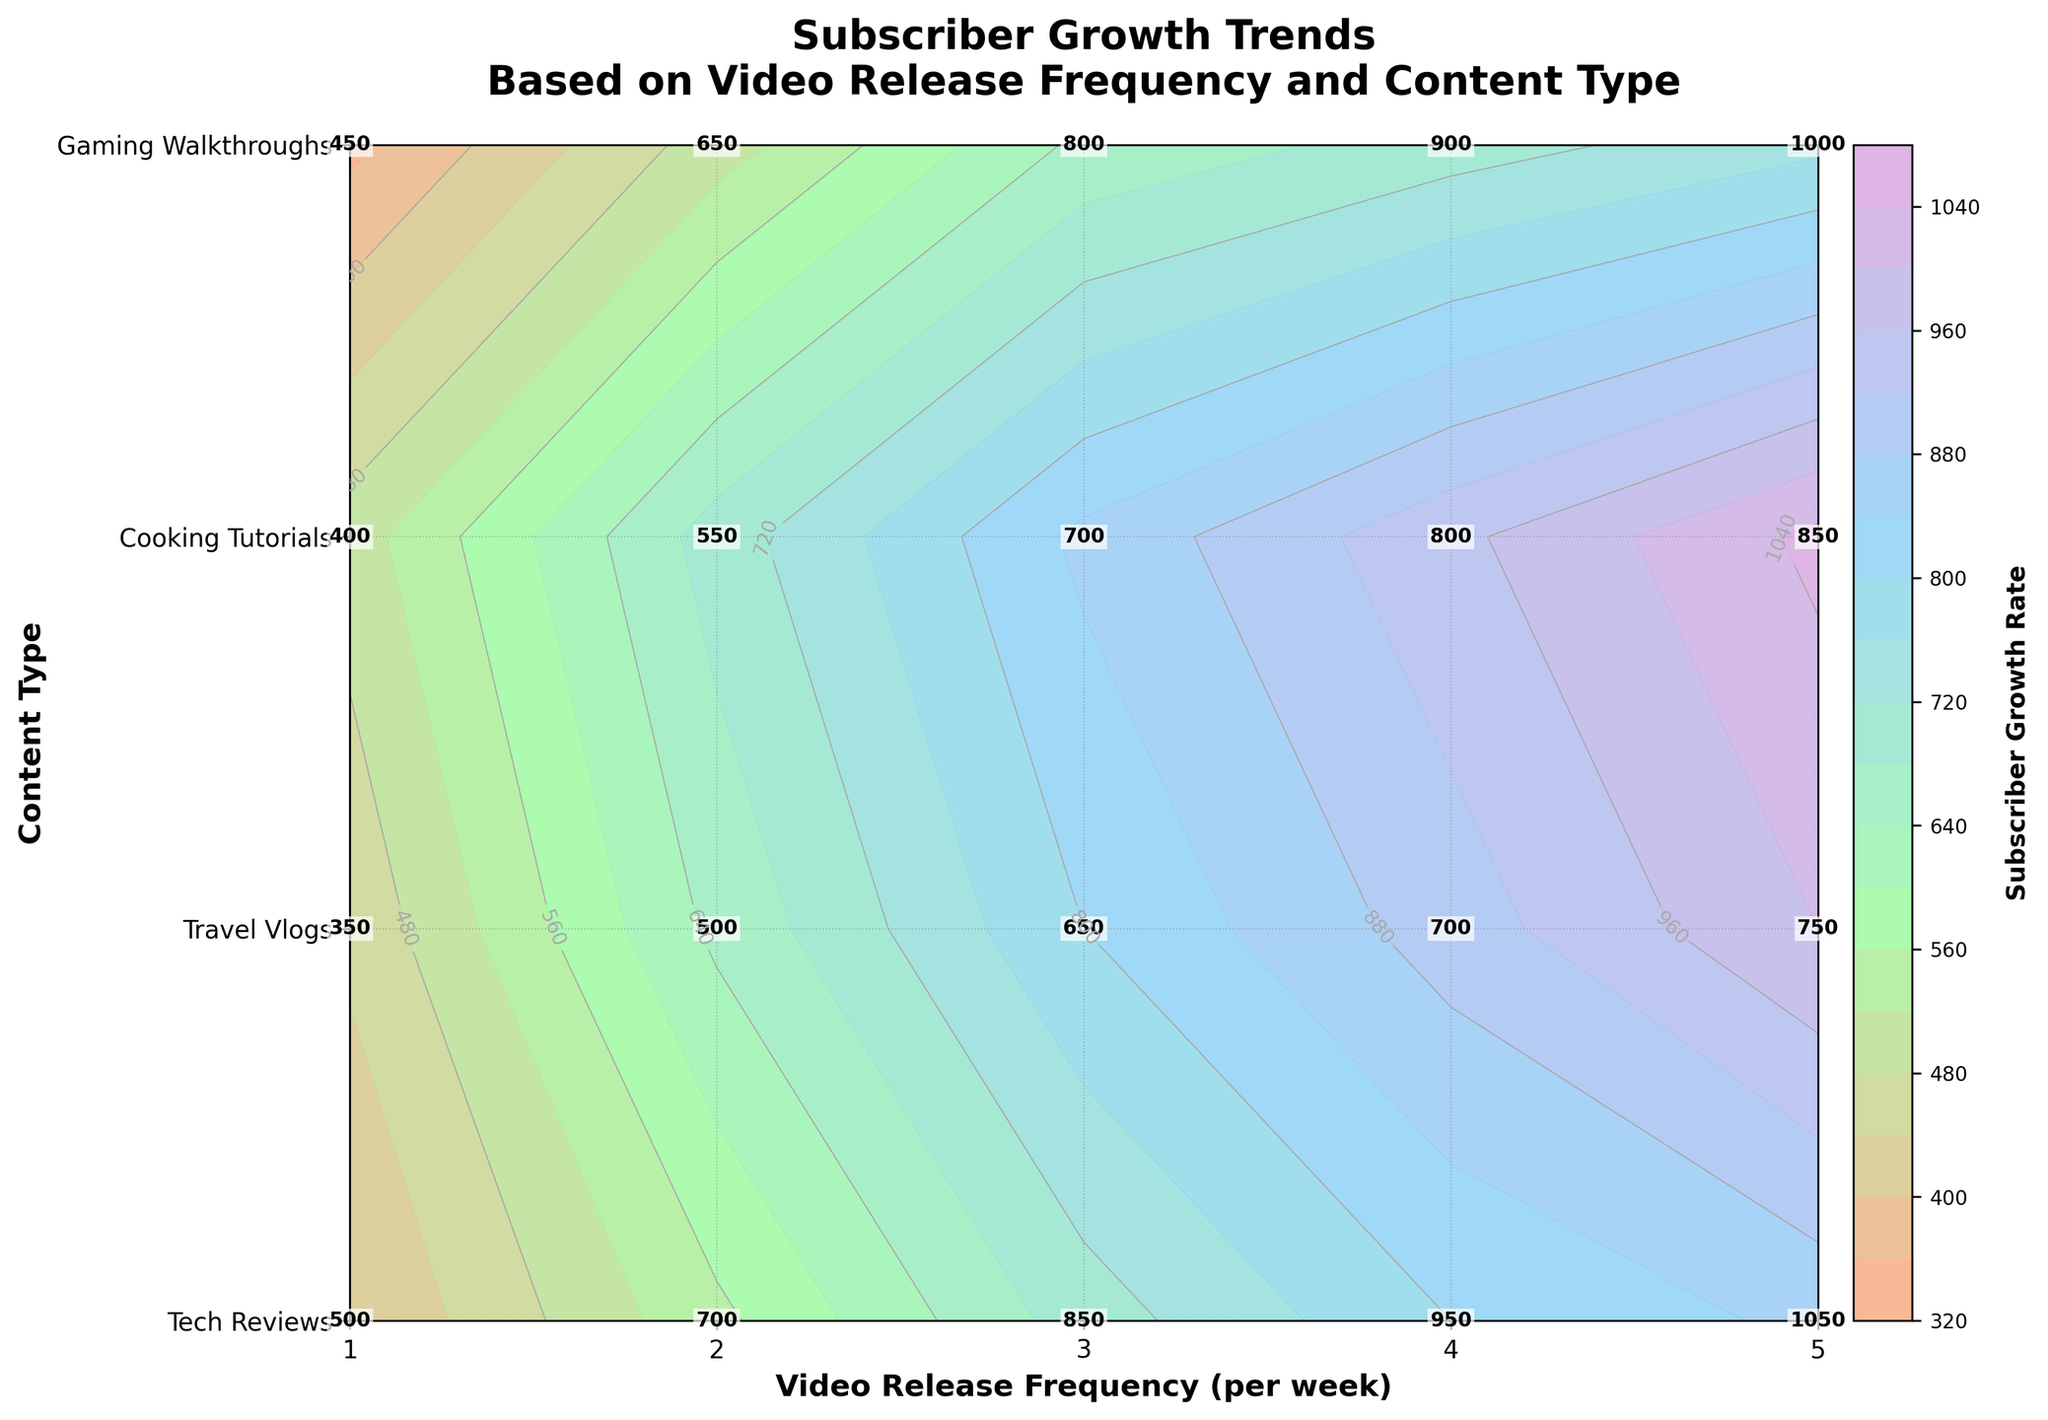Which content type shows the highest subscriber growth rate when releasing one video per week? First, find the 'Video Release Frequency' of 1 on the x-axis. Then, locate the content type that corresponds to the maximum value along that line.
Answer: Tech Reviews What is the subscriber growth rate for Gaming Walkthroughs when releasing four videos per week? Look at the 'Video Release Frequency' of 4 on the x-axis and then find the value where it intersects with 'Gaming Walkthroughs' on the y-axis.
Answer: 900 Which content type shows a consistent increase in subscriber growth rate from one to five videos per week? Observe each content type's growth rate along the x-axis from 1 to 5 videos per week. Identify the content type that consistently has an upward slope.
Answer: Tech Reviews What is the difference in subscriber growth rate between Tech Reviews and Travel Vlogs when releasing three videos per week? Look at the 'Video Release Frequency' of 3 on the x-axis, find the values for Tech Reviews and Travel Vlogs, and then subtract the smaller from the larger. The value for Tech Reviews is 850 and for Travel Vlogs is 650. The difference is 850 - 650.
Answer: 200 How does the growth rate for Cooking Tutorials change when increasing the release frequency from two to four videos per week? Find the 'Video Release Frequency' of 2 and 4 on the x-axis. Note the subscriber growth rates for Cooking Tutorials at these points (550 and 800 respectively), then calculate the difference (800 - 550).
Answer: 250 Among all the content types, which has the lowest growth rate at the maximum video release frequency? Find 'Video Release Frequency' of 5 on the x-axis. Compare the values for all content types at this point and identify the smallest value.
Answer: Travel Vlogs What is the range of subscriber growth rates for Tech Reviews across all video release frequencies? Locate the growth rates for Tech Reviews from 1 to 5 videos per week, then find the range by subtracting the minimum value (500) from the maximum value (1050).
Answer: 550 How does the subscriber growth rate for Gaming Walkthroughs with five videos per week compare to Cooking Tutorials at the same frequency? Look at the 'Video Release Frequency' of 5 on the x-axis for both Gaming Walkthroughs and Cooking Tutorials. Compare their values (1000 and 850 respectively).
Answer: Gaming Walkthroughs have a higher growth rate What is the average subscriber growth rate for Travel Vlogs across all video release frequencies? Sum the growth rates for Travel Vlogs for all frequencies (350, 500, 650, 700, 750) and divide by the number of data points (5). The sum is 2950. Divide 2950 by 5 to get the average.
Answer: 590 How many distinct values are presented in the color bar of the contour plot? Count the distinct levels used in the contour plot for the color bar, which is 20 as per the code in the generation process.
Answer: 20 